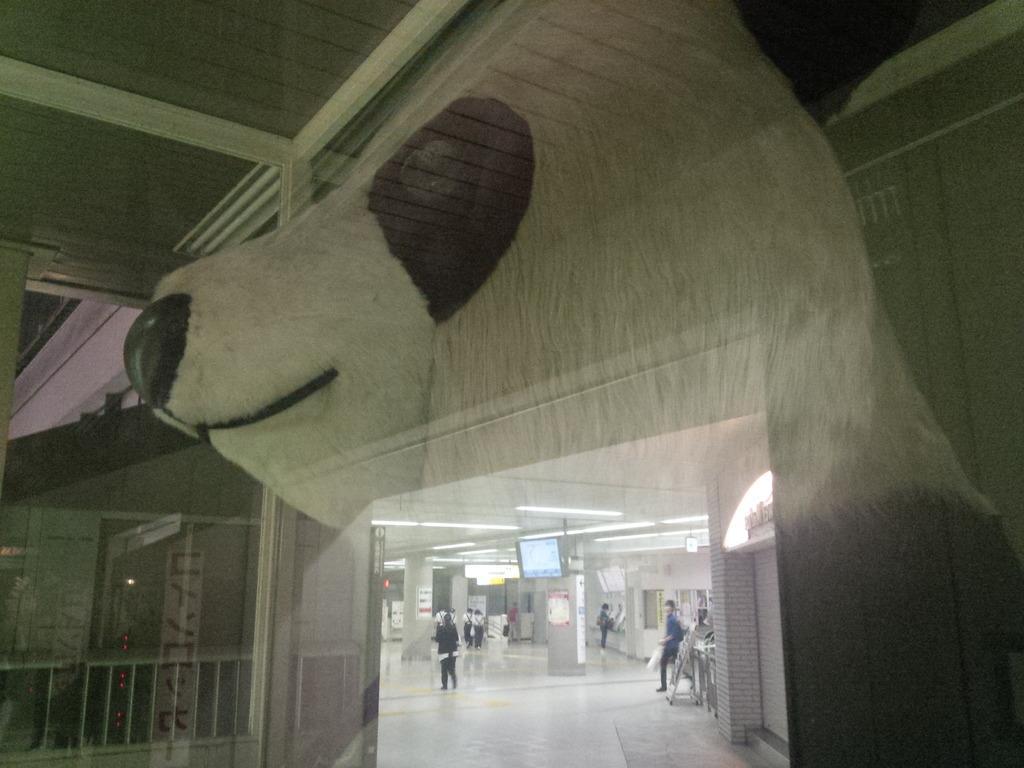Describe this image in one or two sentences. In this image we can see a few people, there are some pillars, there is a TV, we can see the walls, rooftop, also we can see the fence, and a reflection of a teddy bear. 